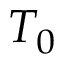<formula> <loc_0><loc_0><loc_500><loc_500>T _ { 0 }</formula> 